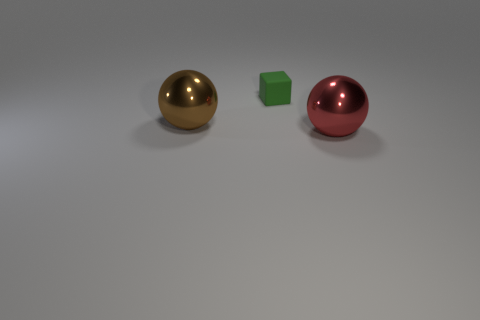Are the objects shown in motion or stationary? The objects in the image are stationary. There are no indications of motion such as blurring or other dynamic elements. The scene's composition gives the impression of a static display, with each object resting firmly on the surface. 